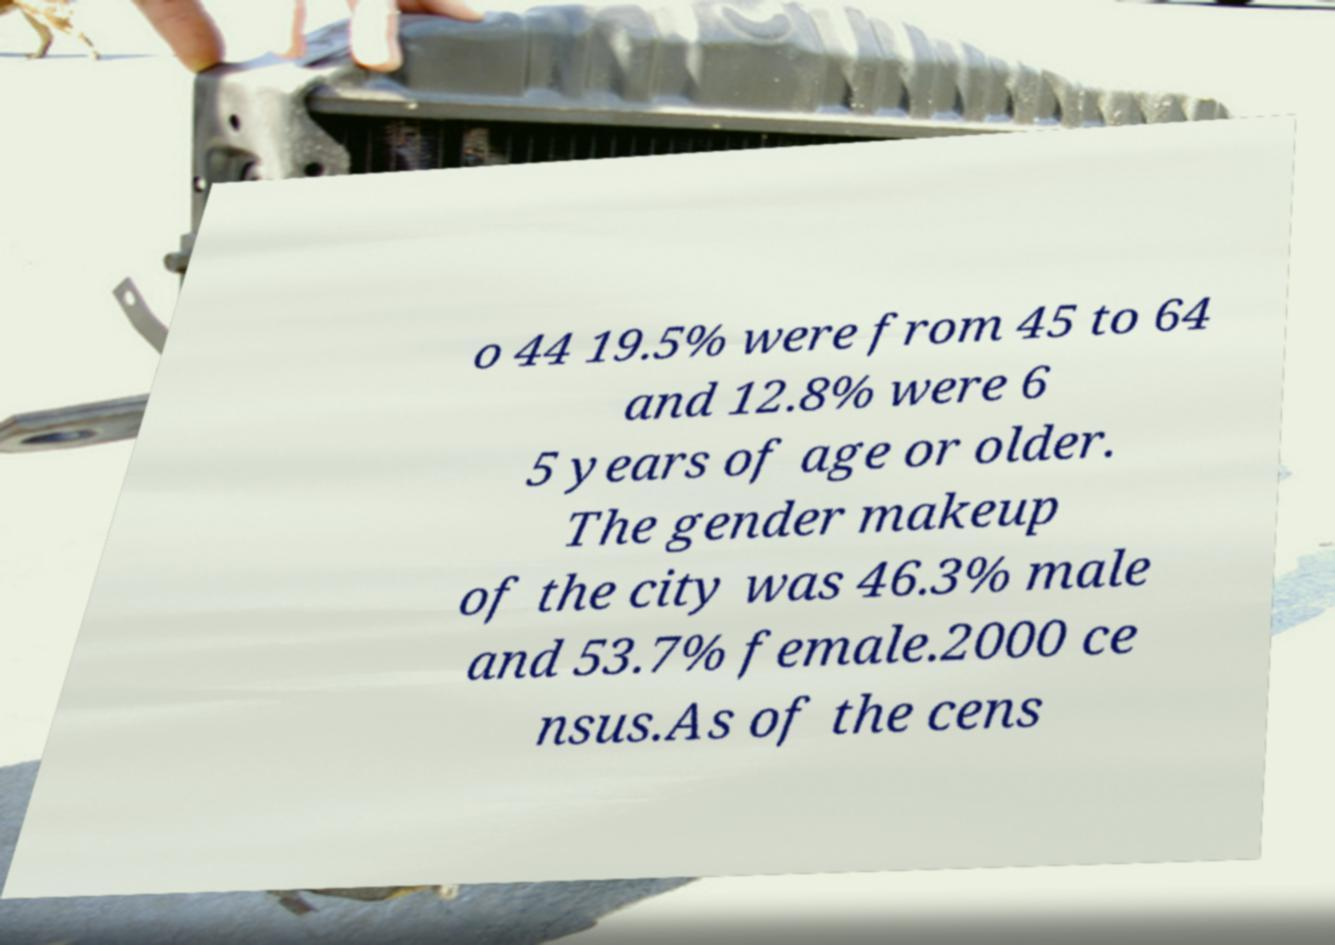Can you accurately transcribe the text from the provided image for me? o 44 19.5% were from 45 to 64 and 12.8% were 6 5 years of age or older. The gender makeup of the city was 46.3% male and 53.7% female.2000 ce nsus.As of the cens 